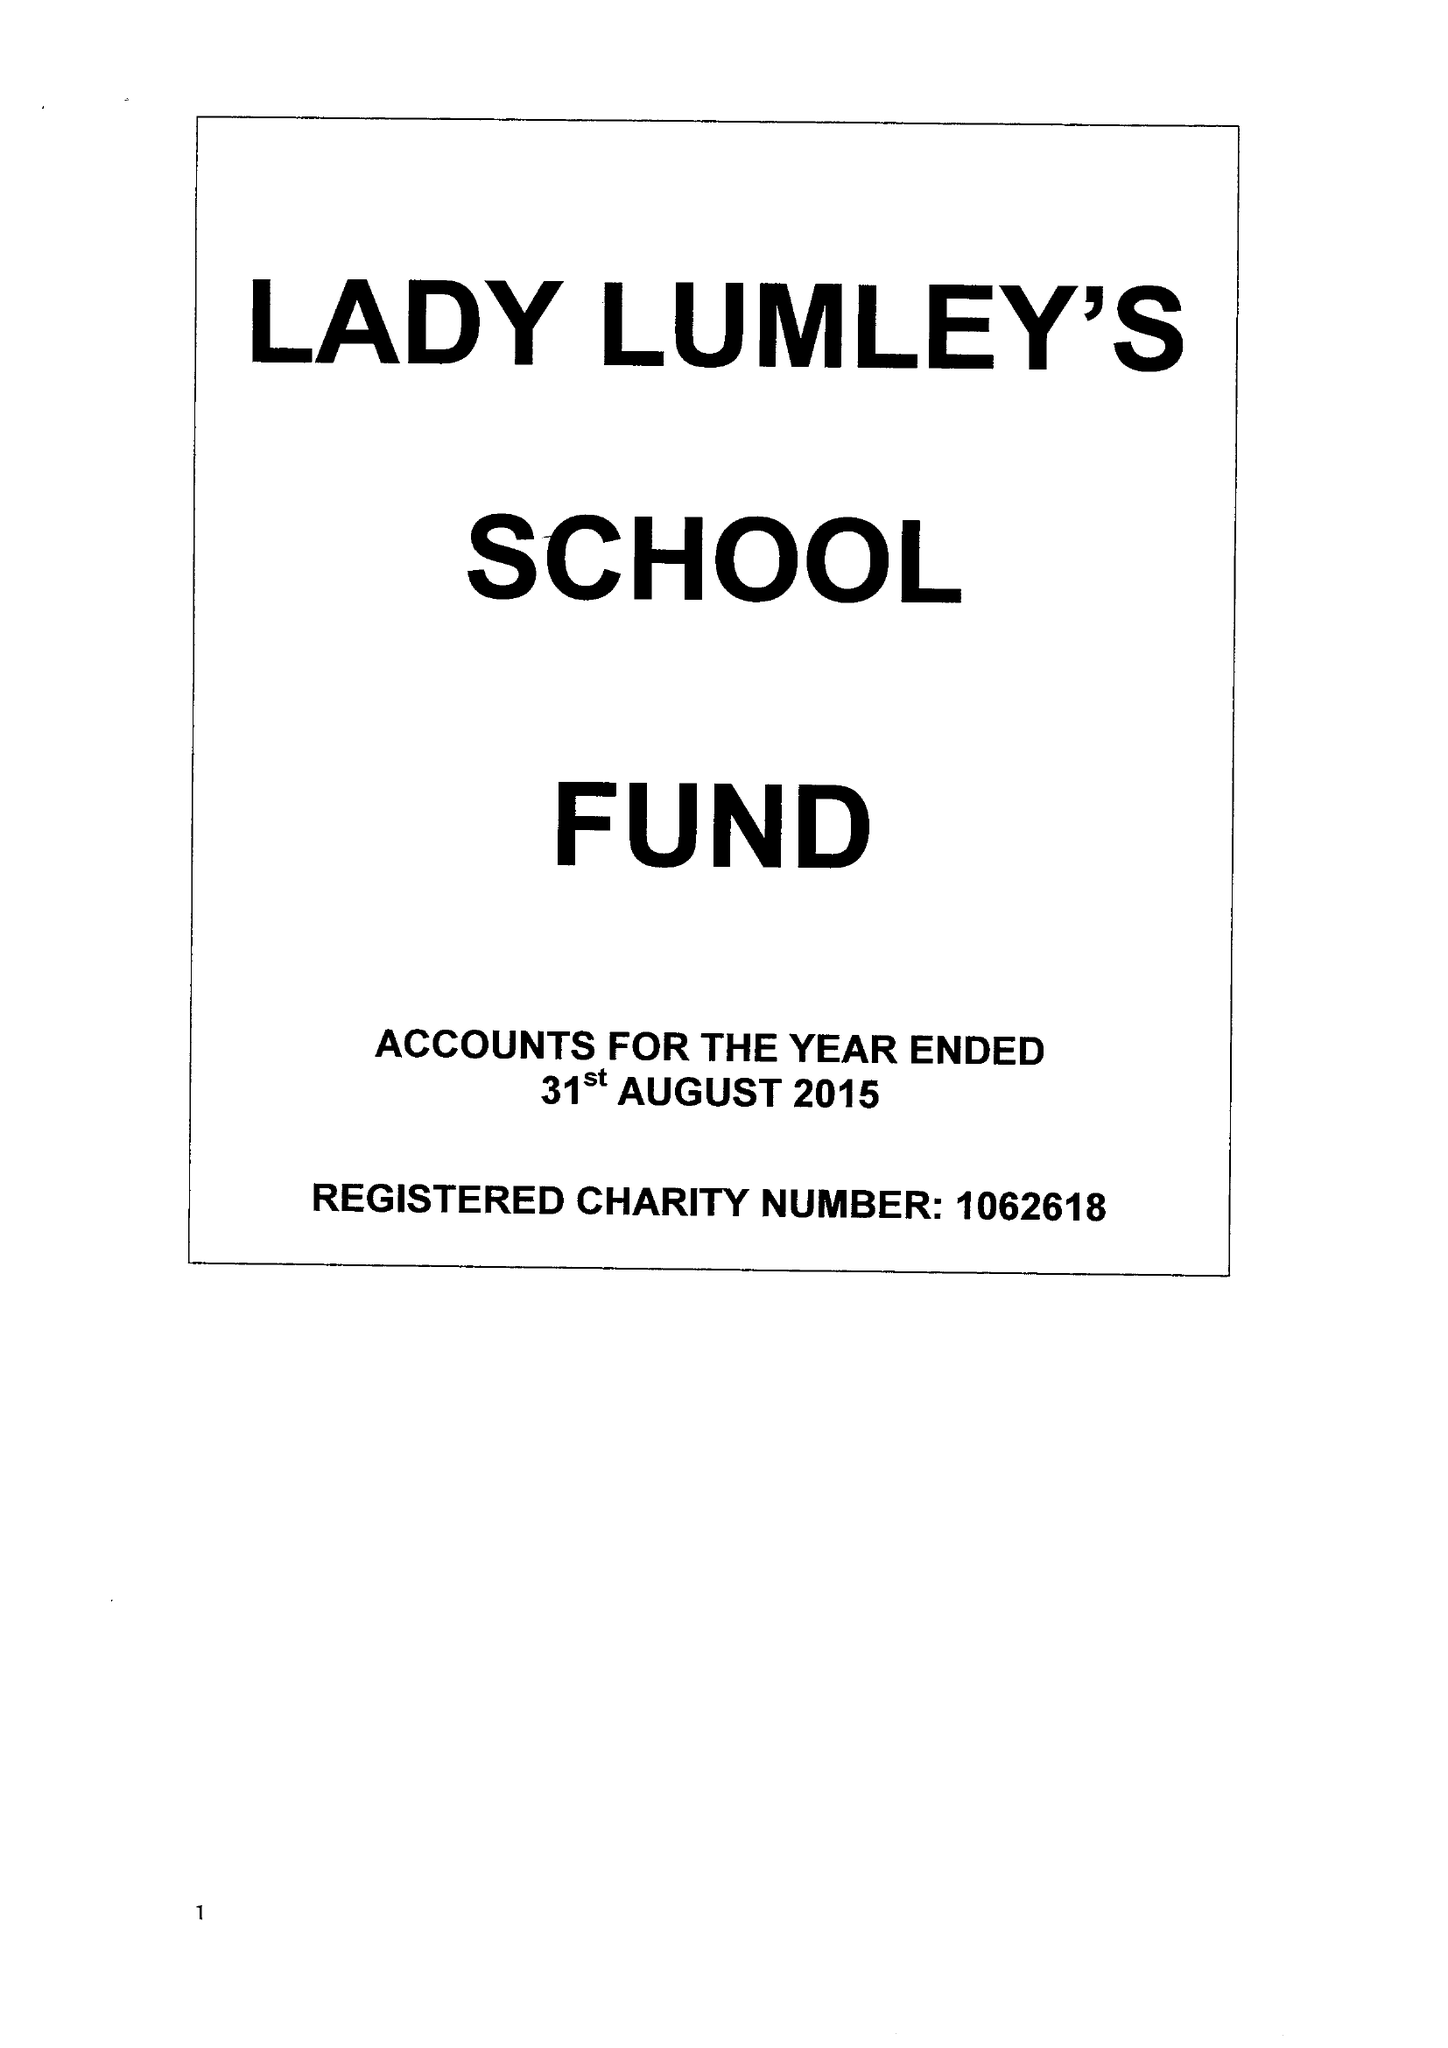What is the value for the charity_name?
Answer the question using a single word or phrase. Lady Lumley's School Fund 